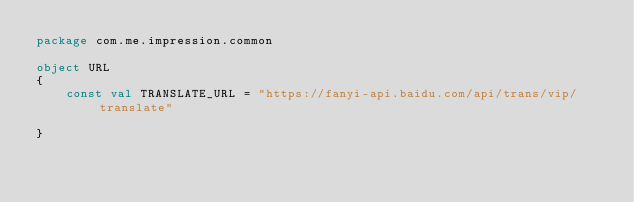<code> <loc_0><loc_0><loc_500><loc_500><_Kotlin_>package com.me.impression.common

object URL
{
    const val TRANSLATE_URL = "https://fanyi-api.baidu.com/api/trans/vip/translate"

}</code> 